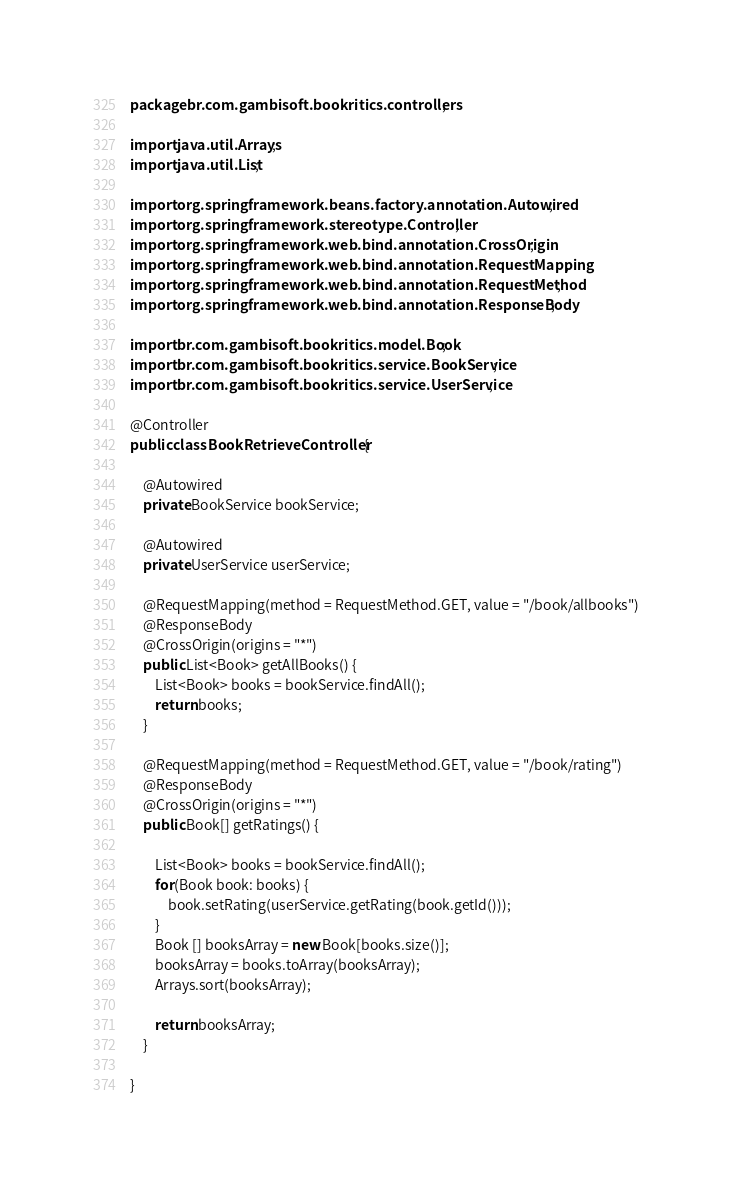Convert code to text. <code><loc_0><loc_0><loc_500><loc_500><_Java_>package br.com.gambisoft.bookritics.controllers;

import java.util.Arrays;
import java.util.List;

import org.springframework.beans.factory.annotation.Autowired;
import org.springframework.stereotype.Controller;
import org.springframework.web.bind.annotation.CrossOrigin;
import org.springframework.web.bind.annotation.RequestMapping;
import org.springframework.web.bind.annotation.RequestMethod;
import org.springframework.web.bind.annotation.ResponseBody;

import br.com.gambisoft.bookritics.model.Book;
import br.com.gambisoft.bookritics.service.BookService;
import br.com.gambisoft.bookritics.service.UserService;

@Controller
public class BookRetrieveController {

	@Autowired
	private BookService bookService;
	
	@Autowired
	private UserService userService;

	@RequestMapping(method = RequestMethod.GET, value = "/book/allbooks")
	@ResponseBody
	@CrossOrigin(origins = "*")
	public List<Book> getAllBooks() {
		List<Book> books = bookService.findAll();
		return books;
	}
	
	@RequestMapping(method = RequestMethod.GET, value = "/book/rating")
	@ResponseBody
	@CrossOrigin(origins = "*")
	public Book[] getRatings() {
		
		List<Book> books = bookService.findAll();
		for(Book book: books) {
			book.setRating(userService.getRating(book.getId()));
		}
		Book [] booksArray = new Book[books.size()];
		booksArray = books.toArray(booksArray);
		Arrays.sort(booksArray);
		
		return booksArray;
	}

}
</code> 